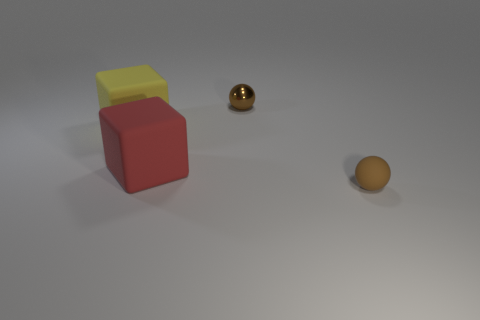What's the likely size of these objects in comparison to each other? The objects exhibit varying sizes; the red cube has the largest visible volume, followed by the yellow cube, which is smaller and placed on top of the red one. The spherical object, while closer to the vantage point, appears to be smaller in size than the cubes. 